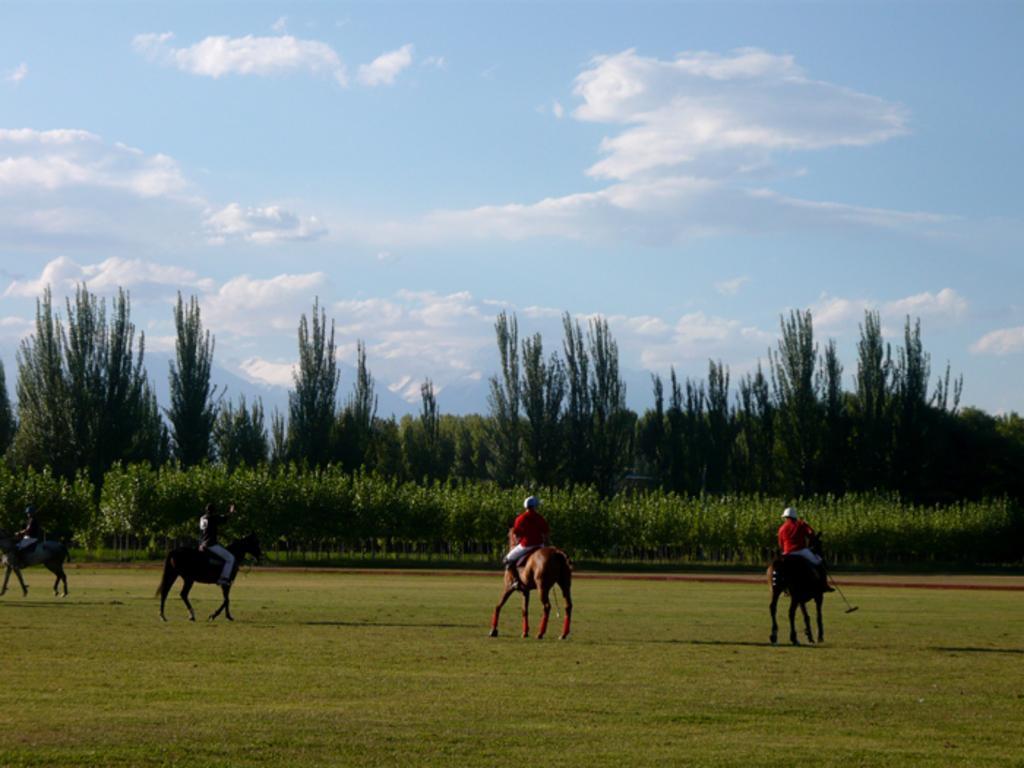Describe this image in one or two sentences. In this image in the center there are persons sitting on horses. In the background there are trees and the sky is cloudy and there's grass on the ground. 